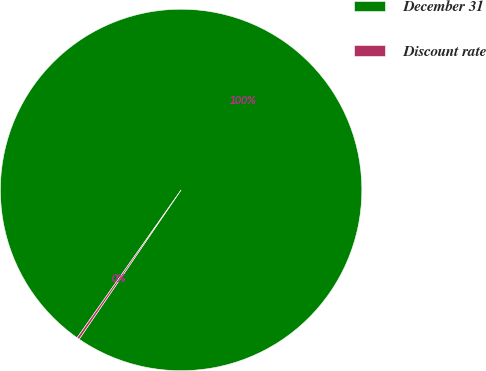Convert chart to OTSL. <chart><loc_0><loc_0><loc_500><loc_500><pie_chart><fcel>December 31<fcel>Discount rate<nl><fcel>99.78%<fcel>0.22%<nl></chart> 